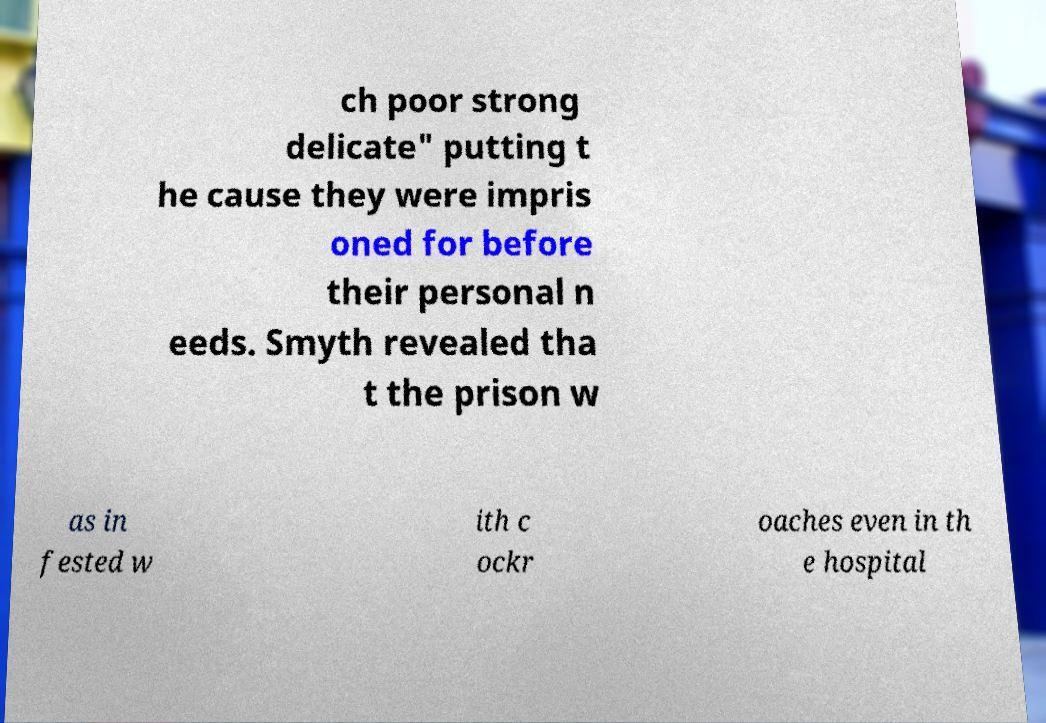Could you extract and type out the text from this image? ch poor strong delicate" putting t he cause they were impris oned for before their personal n eeds. Smyth revealed tha t the prison w as in fested w ith c ockr oaches even in th e hospital 